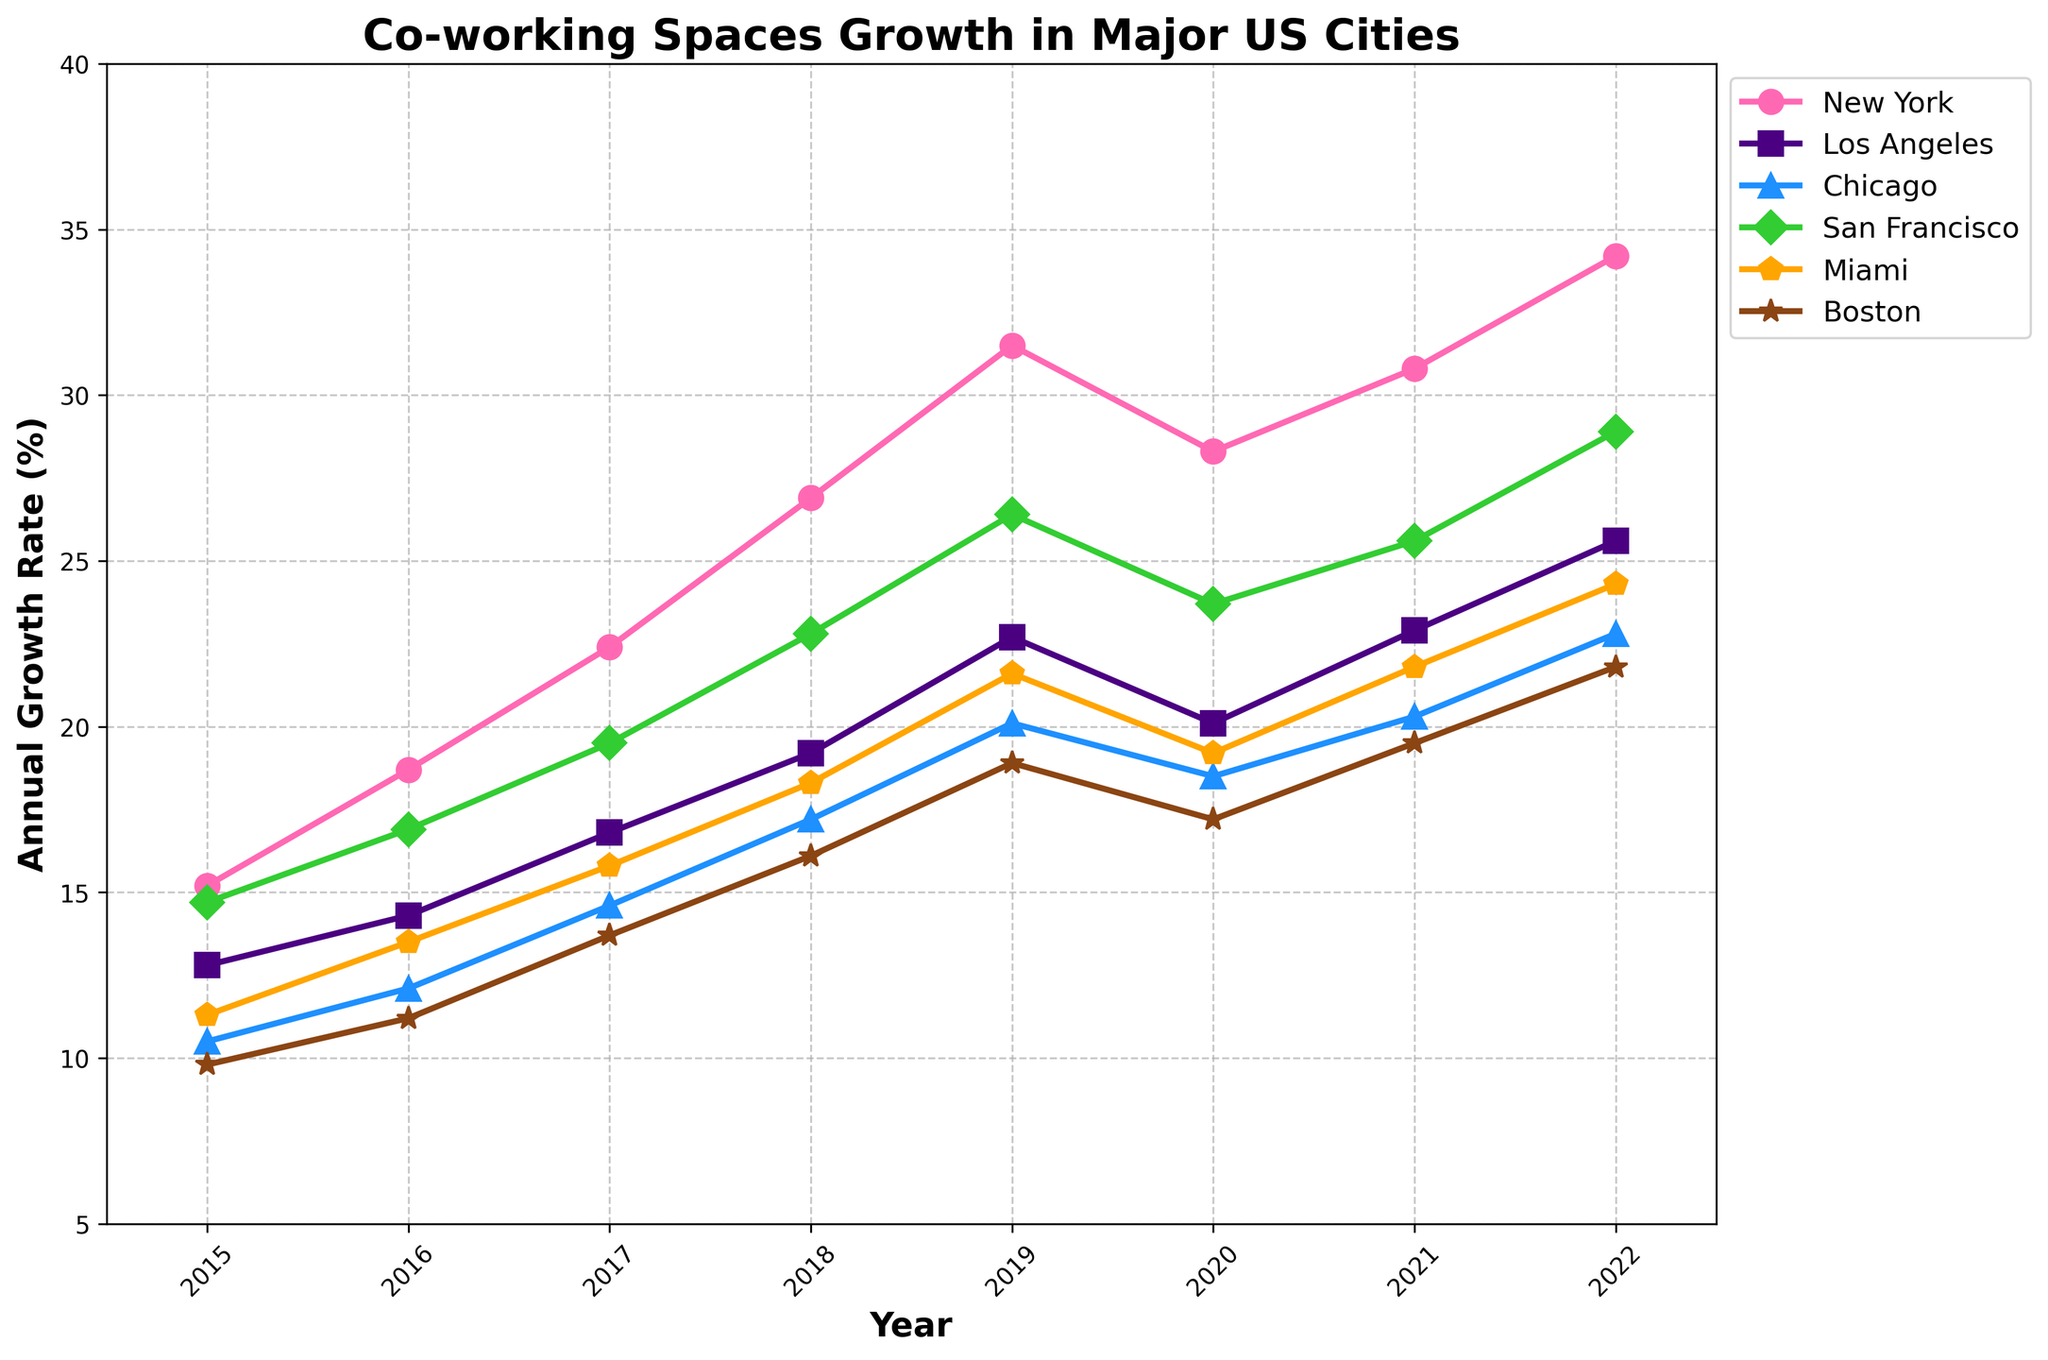How much did the annual growth rate of co-working spaces in New York increase from 2015 to 2022? The growth rate in New York in 2015 was 15.2% and in 2022 it was 34.2%. The increase is 34.2 - 15.2.
Answer: 19.0% During which year did San Francisco reach its peak annual growth rate? San Francisco's peak annual growth rate was the highest value on the San Francisco line in the plot. The peak rate of 28.9% occurred in 2022.
Answer: 2022 Between 2019 and 2022, which city had the smallest change in annual growth rate? Calculate the difference in growth rate between 2019 and 2022 for each city, then compare them. New York: 34.2-31.5=2.7, Los Angeles: 25.6-22.7=2.9, Chicago: 22.8-20.1=2.7, San Francisco: 28.9-26.4=2.5, Miami: 24.3-21.6=2.7, Boston: 21.8-18.9=2.9. The smallest change in growth rate occurred in San Francisco with 2.5%.
Answer: San Francisco What was the average annual growth rate of co-working spaces in Boston over the 8-year period (2015-2022)? The average annual growth rate is the sum of each year's rate divided by the number of years. The rates for Boston are 9.8, 11.2, 13.7, 16.1, 18.9, 17.2, 19.5, 21.8. (9.8+11.2+13.7+16.1+18.9+17.2+19.5+21.8)/8 = 127.9/8 = 16.0%
Answer: 16.0% Which city had a higher growth rate in 2020, Los Angeles or Chicago? The growth rate of Los Angeles in 2020 is 20.1%, and for Chicago, it is 18.5%. Therefore, Los Angeles had a higher growth rate in 2020.
Answer: Los Angeles In what year did New York surpass a 30% annual growth rate? The first year New York surpassed 30% as observed on the New York line is between 2019 and 2020. In 2019 it was 31.5%.
Answer: 2019 How did the annual growth rate for Miami change from 2015 to 2020 and then from 2020 to 2022? Miami's rate in 2015 was 11.3% and in 2020 was 19.2%, giving a change of 19.2 - 11.3 = 7.9% for the first period. From 2020 to 2022, the change is 24.3 - 19.2, which is 5.1%.
Answer: 7.9% and 5.1% Which city had the steepest drop in growth rate from 2019 to 2020? The steepest drop can be identified by finding the largest negative difference for each city between these two years. New York: 28.3-31.5=-3.2%, Los Angeles: 20.1-22.7=-2.6%, Chicago: 18.5-20.1=-1.6%, San Francisco: 23.7-26.4=-2.7%, Miami: 19.2-21.6=-2.4%, Boston: 17.2-18.9=-1.7%. The largest drop of -3.2% occurred in New York.
Answer: New York 